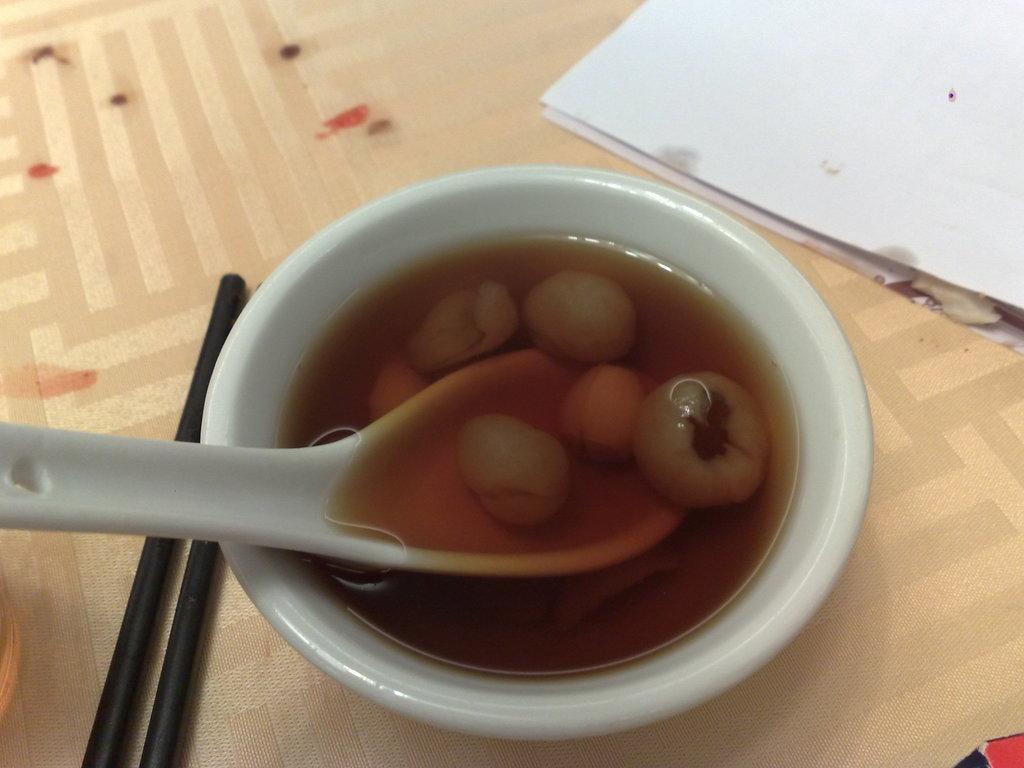Describe this image in one or two sentences. In this image we can see some food item and spoon are kept in the white color bowl and we can see chop sticks and papers are kept on the surface. 